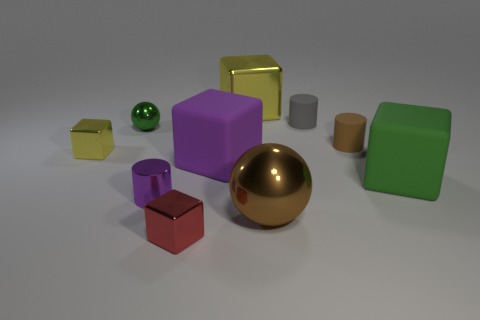Subtract all big green matte blocks. How many blocks are left? 4 Subtract all green spheres. How many spheres are left? 1 Subtract 4 cubes. How many cubes are left? 1 Subtract all gray blocks. How many yellow cylinders are left? 0 Subtract all small red shiny blocks. Subtract all big green things. How many objects are left? 8 Add 9 small brown cylinders. How many small brown cylinders are left? 10 Add 5 cyan spheres. How many cyan spheres exist? 5 Subtract 1 brown cylinders. How many objects are left? 9 Subtract all cylinders. How many objects are left? 7 Subtract all brown blocks. Subtract all red spheres. How many blocks are left? 5 